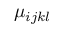Convert formula to latex. <formula><loc_0><loc_0><loc_500><loc_500>\mu _ { i j k l }</formula> 